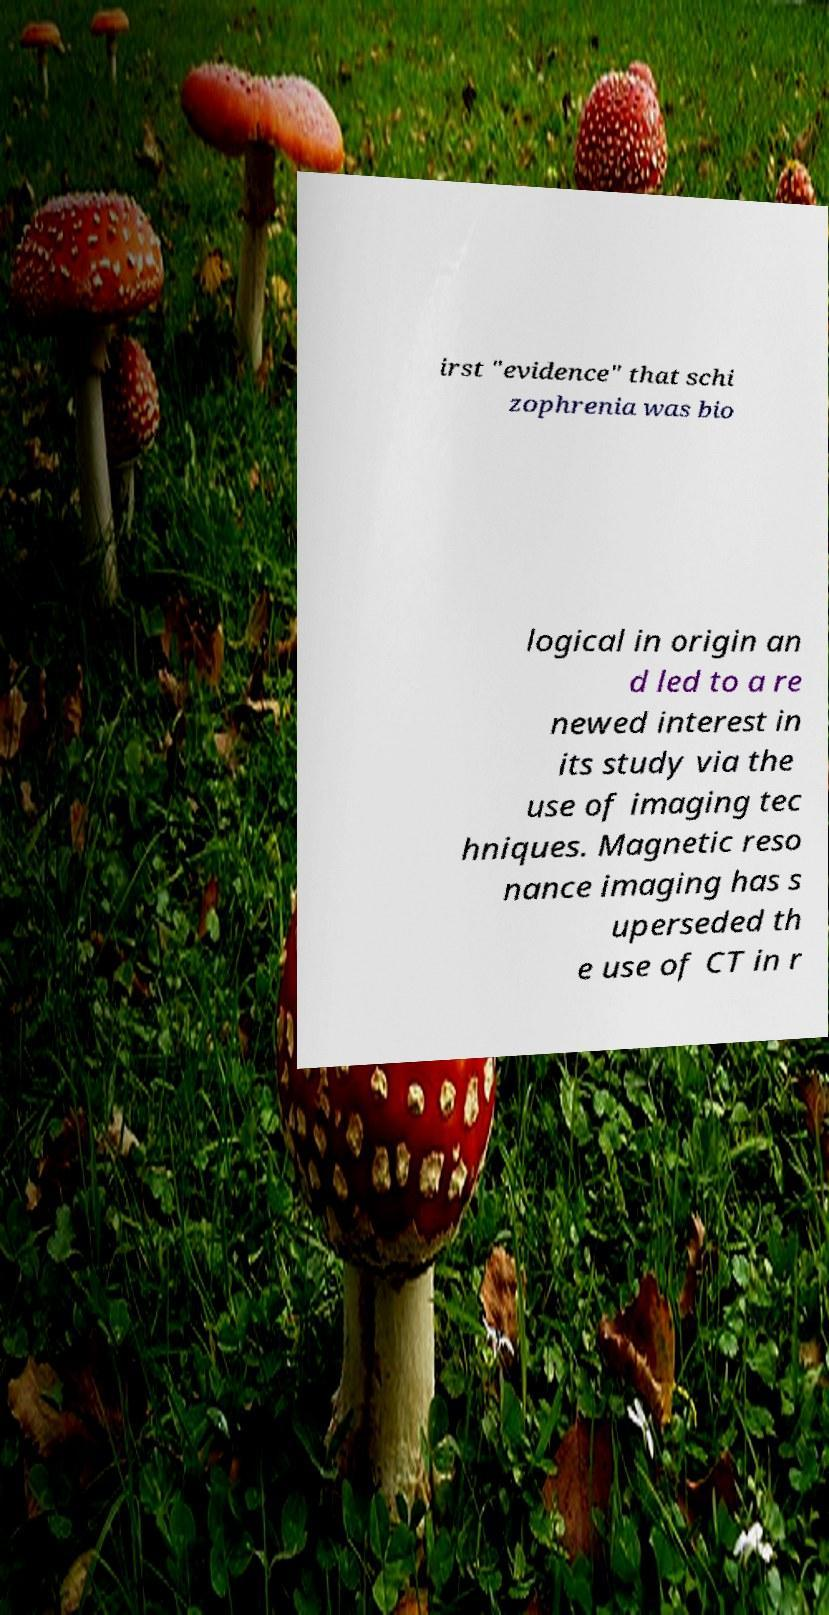Could you extract and type out the text from this image? irst "evidence" that schi zophrenia was bio logical in origin an d led to a re newed interest in its study via the use of imaging tec hniques. Magnetic reso nance imaging has s uperseded th e use of CT in r 